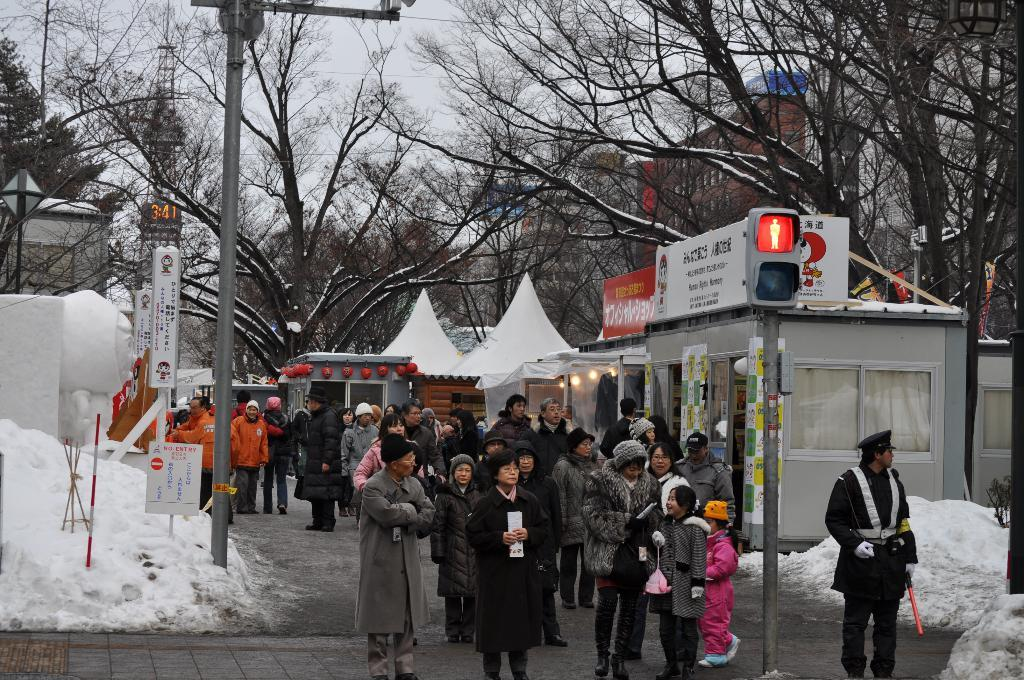What is the main subject of the image? There is a group of people in the image. What is located on the pole in the image? There is a traffic signal on a pole. What objects can be seen in the image besides the people and traffic signal? There are boards visible in the image. What is the weather like in the image? There is snow in the image, indicating a cold or wintry environment. What can be seen in the background of the image? The background of the image includes trees, buildings, and the sky. Can you see any pigs stuck in quicksand in the image? No, there are no pigs or quicksand present in the image. What type of bone can be seen in the image? There is no bone visible in the image. 